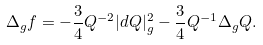Convert formula to latex. <formula><loc_0><loc_0><loc_500><loc_500>\Delta _ { g } f = - \frac { 3 } { 4 } Q ^ { - 2 } | d Q | ^ { 2 } _ { g } - \frac { 3 } { 4 } Q ^ { - 1 } \Delta _ { g } Q .</formula> 